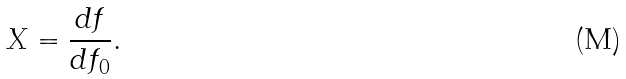Convert formula to latex. <formula><loc_0><loc_0><loc_500><loc_500>X = \frac { d f } { d f _ { 0 } } .</formula> 